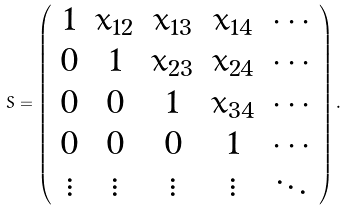<formula> <loc_0><loc_0><loc_500><loc_500>S = \left ( \begin{array} { c c c c c } 1 & x _ { 1 2 } & x _ { 1 3 } & x _ { 1 4 } & \cdots \\ 0 & 1 & x _ { 2 3 } & x _ { 2 4 } & \cdots \\ 0 & 0 & 1 & x _ { 3 4 } & \cdots \\ 0 & 0 & 0 & 1 & \cdots \\ \vdots & \vdots & \vdots & \vdots & \ddots \end{array} \right ) .</formula> 